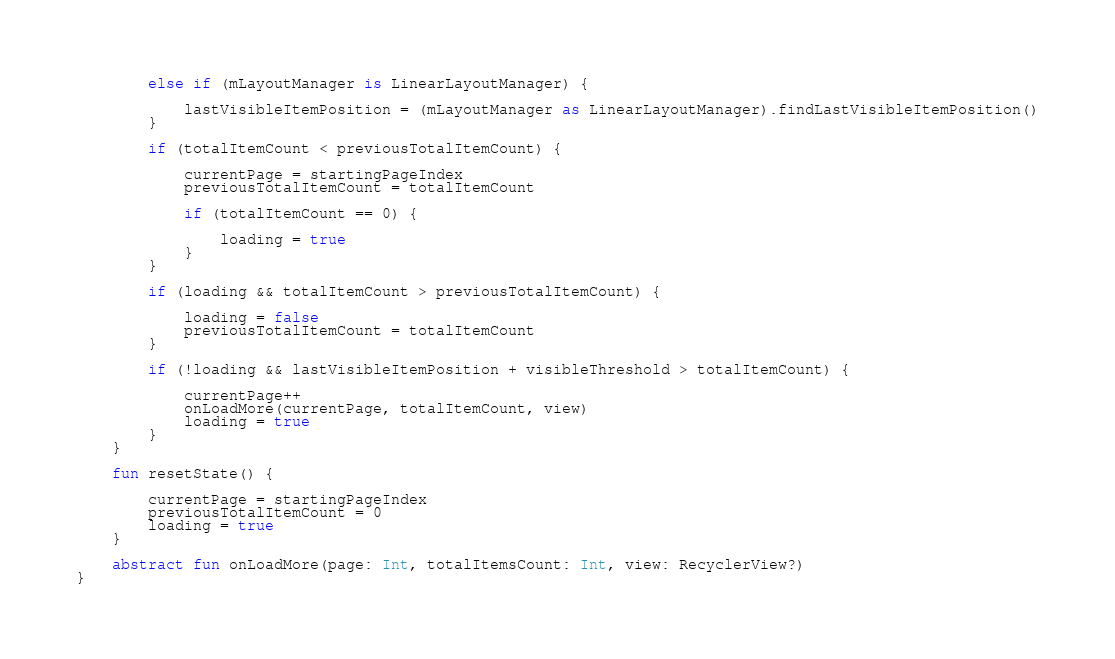<code> <loc_0><loc_0><loc_500><loc_500><_Kotlin_>
        else if (mLayoutManager is LinearLayoutManager) {

            lastVisibleItemPosition = (mLayoutManager as LinearLayoutManager).findLastVisibleItemPosition()
        }

        if (totalItemCount < previousTotalItemCount) {

            currentPage = startingPageIndex
            previousTotalItemCount = totalItemCount

            if (totalItemCount == 0) {

                loading = true
            }
        }

        if (loading && totalItemCount > previousTotalItemCount) {

            loading = false
            previousTotalItemCount = totalItemCount
        }

        if (!loading && lastVisibleItemPosition + visibleThreshold > totalItemCount) {

            currentPage++
            onLoadMore(currentPage, totalItemCount, view)
            loading = true
        }
    }

    fun resetState() {

        currentPage = startingPageIndex
        previousTotalItemCount = 0
        loading = true
    }

    abstract fun onLoadMore(page: Int, totalItemsCount: Int, view: RecyclerView?)
}</code> 